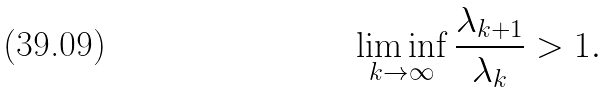Convert formula to latex. <formula><loc_0><loc_0><loc_500><loc_500>\liminf _ { k \to \infty } \frac { \lambda _ { k + 1 } } { \lambda _ { k } } > 1 .</formula> 